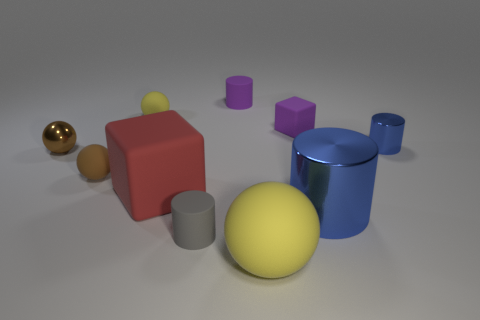Subtract all tiny spheres. How many spheres are left? 1 Subtract all brown balls. How many balls are left? 2 Subtract all cubes. How many objects are left? 8 Subtract 2 spheres. How many spheres are left? 2 Subtract all gray cubes. How many red cylinders are left? 0 Subtract all purple blocks. Subtract all large blue objects. How many objects are left? 8 Add 9 large red rubber things. How many large red rubber things are left? 10 Add 4 red matte objects. How many red matte objects exist? 5 Subtract 1 red blocks. How many objects are left? 9 Subtract all blue spheres. Subtract all yellow cubes. How many spheres are left? 4 